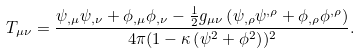<formula> <loc_0><loc_0><loc_500><loc_500>T _ { \mu \nu } = \frac { \psi _ { , \mu } \psi _ { , \nu } + \phi _ { , \mu } \phi _ { , \nu } - \frac { 1 } { 2 } g _ { \mu \nu } \left ( \psi _ { , \rho } \psi ^ { , \rho } + \phi _ { , \rho } \phi ^ { , \rho } \right ) } { 4 \pi ( 1 - \kappa \left ( \psi ^ { 2 } + \phi ^ { 2 } \right ) ) ^ { 2 } } .</formula> 